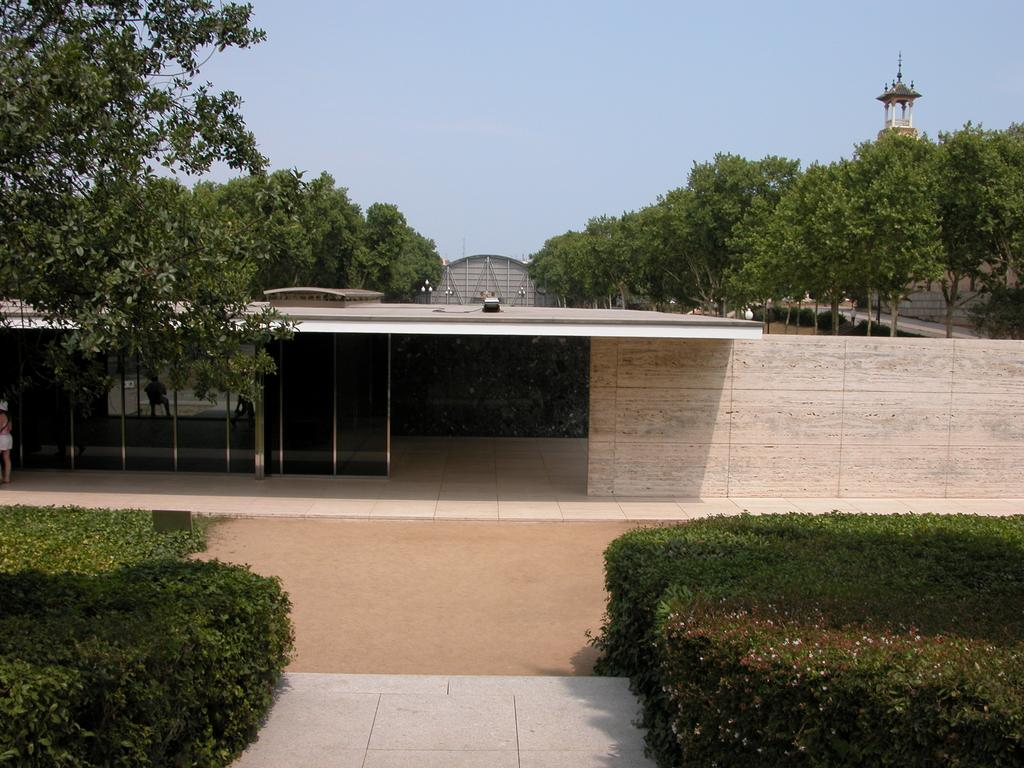What is located on the left side of the image? There are plants on the left side of the image. What is located on the right side of the image? There are plants on the right side of the image. What can be seen in the middle of the image? There is a path in the middle of the image. What is visible on the ground in the image? The ground is visible in the image. What can be seen in the background of the image? There are trees, buildings, and plants in the background of the image. What is visible in the sky in the image? The sky is visible in the background of the image. What type of art is being created by the servant in the background of the image? There is no servant or art creation present in the image. What type of industry can be seen in the background of the image? There is no industry present in the image; it features plants, trees, buildings, and the sky. 